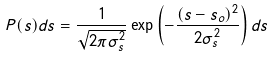Convert formula to latex. <formula><loc_0><loc_0><loc_500><loc_500>P ( s ) d s = \frac { 1 } { \sqrt { 2 \pi \sigma _ { s } ^ { 2 } } } \exp \left ( - \frac { ( s - s _ { o } ) ^ { 2 } } { 2 \sigma _ { s } ^ { 2 } } \right ) d s</formula> 